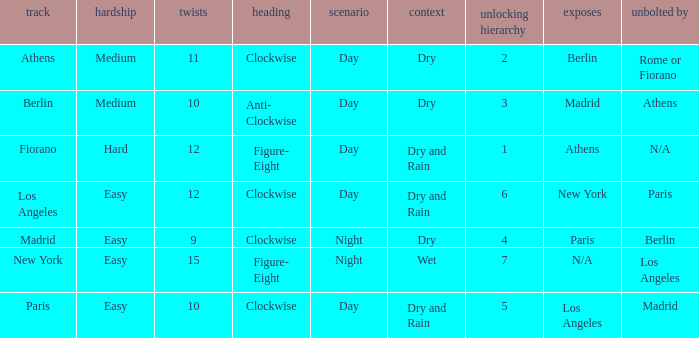What is the lowest unlock order for the athens circuit? 2.0. Can you parse all the data within this table? {'header': ['track', 'hardship', 'twists', 'heading', 'scenario', 'context', 'unlocking hierarchy', 'exposes', 'unbolted by'], 'rows': [['Athens', 'Medium', '11', 'Clockwise', 'Day', 'Dry', '2', 'Berlin', 'Rome or Fiorano'], ['Berlin', 'Medium', '10', 'Anti- Clockwise', 'Day', 'Dry', '3', 'Madrid', 'Athens'], ['Fiorano', 'Hard', '12', 'Figure- Eight', 'Day', 'Dry and Rain', '1', 'Athens', 'N/A'], ['Los Angeles', 'Easy', '12', 'Clockwise', 'Day', 'Dry and Rain', '6', 'New York', 'Paris'], ['Madrid', 'Easy', '9', 'Clockwise', 'Night', 'Dry', '4', 'Paris', 'Berlin'], ['New York', 'Easy', '15', 'Figure- Eight', 'Night', 'Wet', '7', 'N/A', 'Los Angeles'], ['Paris', 'Easy', '10', 'Clockwise', 'Day', 'Dry and Rain', '5', 'Los Angeles', 'Madrid']]} 